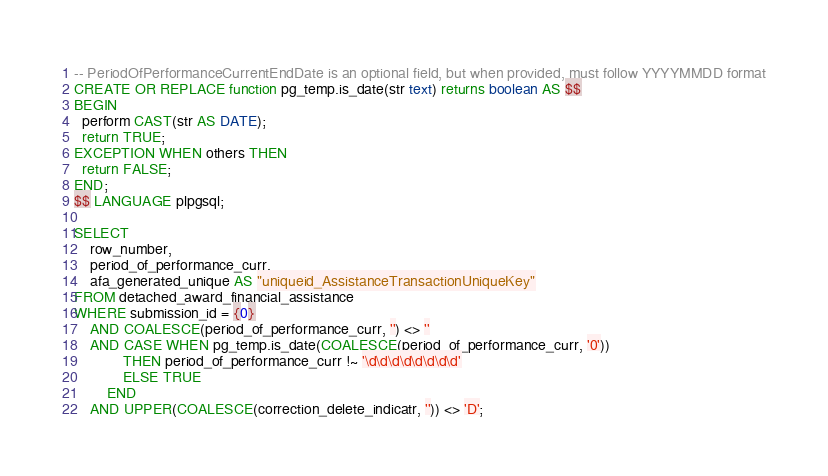<code> <loc_0><loc_0><loc_500><loc_500><_SQL_>-- PeriodOfPerformanceCurrentEndDate is an optional field, but when provided, must follow YYYYMMDD format
CREATE OR REPLACE function pg_temp.is_date(str text) returns boolean AS $$
BEGIN
  perform CAST(str AS DATE);
  return TRUE;
EXCEPTION WHEN others THEN
  return FALSE;
END;
$$ LANGUAGE plpgsql;

SELECT
    row_number,
    period_of_performance_curr,
    afa_generated_unique AS "uniqueid_AssistanceTransactionUniqueKey"
FROM detached_award_financial_assistance
WHERE submission_id = {0}
    AND COALESCE(period_of_performance_curr, '') <> ''
    AND CASE WHEN pg_temp.is_date(COALESCE(period_of_performance_curr, '0'))
            THEN period_of_performance_curr !~ '\d\d\d\d\d\d\d\d'
            ELSE TRUE
        END
    AND UPPER(COALESCE(correction_delete_indicatr, '')) <> 'D';
</code> 